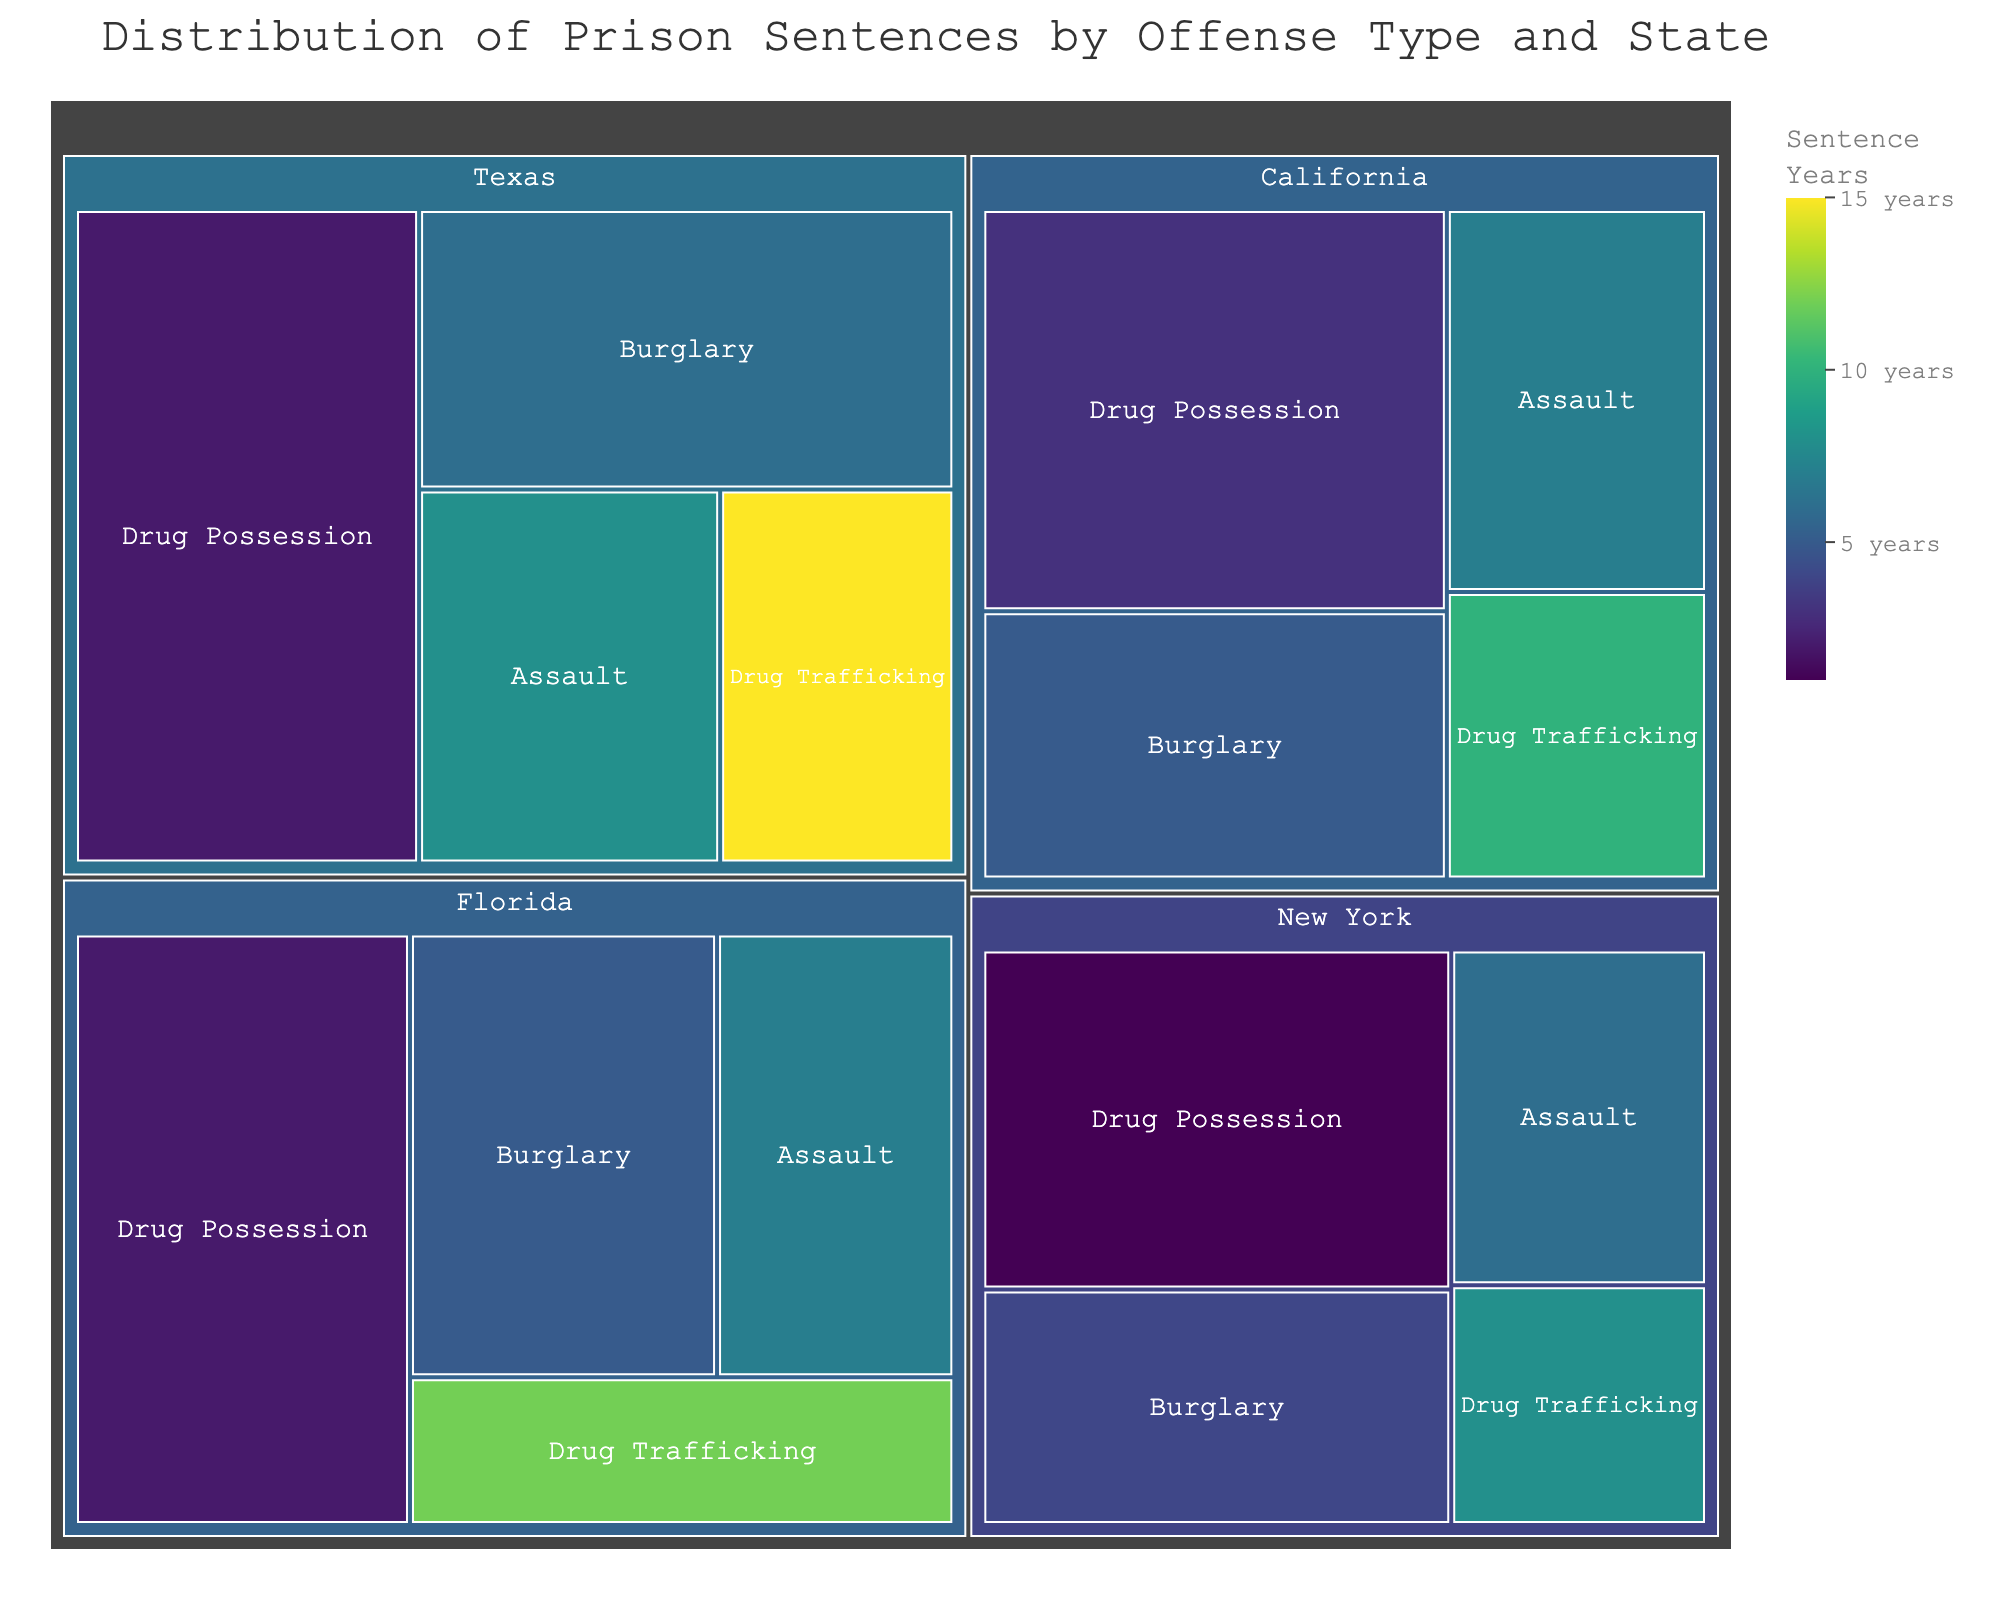What's the title of the figure? The title of the figure is displayed prominently at the top of the treemap. It provides a brief description of what the figure represents.
Answer: Distribution of Prison Sentences by Offense Type and State Which state has the highest count for Drug Possession offenses? By observing the treemap, identify the state with the largest tile for the Drug Possession offense based on the count value.
Answer: Texas How many years is the average sentence for Drug Trafficking in Texas? Hovering over the Drug Trafficking tile in Texas shows the average sentence in years.
Answer: 15 years Which offense in California has the highest average sentence? Compare the average sentence years for each offense in California by examining the color scale and looking at the hover data.
Answer: Drug Trafficking What is the combined count of Burglary offenses in Texas and Florida? Add the count of Burglary offenses in Texas and in Florida. Texas has 120 and Florida has 110, so 120 + 110 = 230.
Answer: 230 Which offense has the lowest average sentence in New York? Compare the average sentence years for each offense in New York by examining the color scale and looking at the hover data for each offense.
Answer: Drug Possession What is the total count of all offenses in California? Sum the count of all offenses in California: Drug Possession (150) + Burglary (100) + Assault (80) + Drug Trafficking (60) = 390.
Answer: 390 Which state has the highest number of Assault offenses? Identify the state with the largest tile for Assault offenses based on the count value.
Answer: Texas How does the average sentence length for Burglary in New York compare to that in California? Hover over the Burglary tiles in both New York and California and compare the average sentence years. New York is 4 years and California is 5 years.
Answer: New York: 4 years, California: 5 years What is the color range representing the average sentence years? Examine the color bar legend on the right side of the treemap to see the range it covers.
Answer: 1 to 15 years 